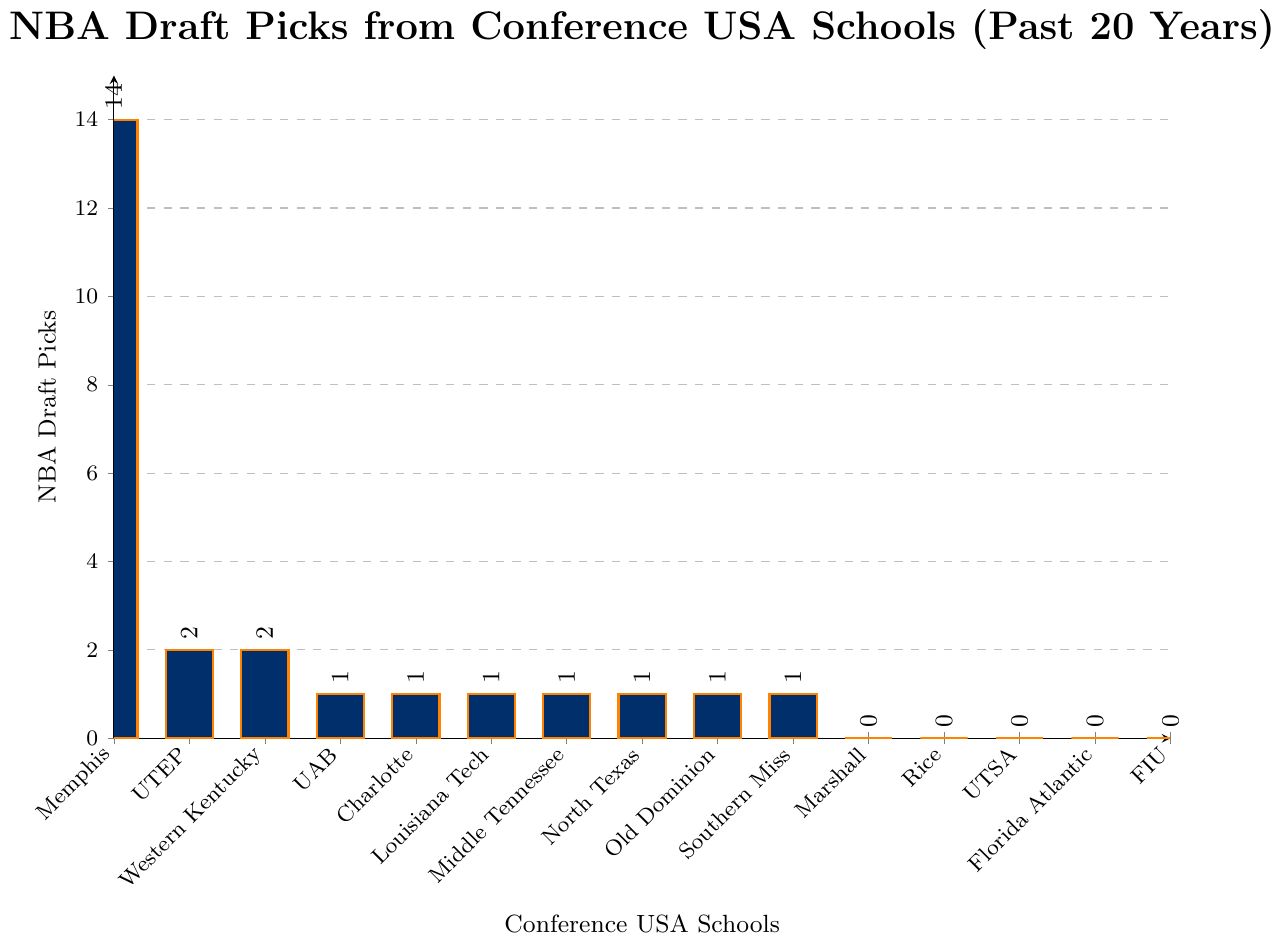Which school has the highest number of NBA draft picks? The tallest bar in the chart corresponds to Memphis, indicating it has the highest number of NBA draft picks.
Answer: Memphis How many schools have had exactly 1 NBA draft pick? Count the number of bars representing 1 draft pick. The schools are UAB, Charlotte, Louisiana Tech, Middle Tennessee, North Texas, Old Dominion, and Southern Miss.
Answer: 7 What is the total number of NBA draft picks from Conference USA schools represented in the chart? Add the NBA draft picks of all the schools: 14 (Memphis) + 2 (UTEP) + 2 (Western Kentucky) + 1 (UAB) + 1 (Charlotte) + 1 (Louisiana Tech) + 1 (Middle Tennessee) + 1 (North Texas) + 1 (Old Dominion) + 1 (Southern Miss) + 0 (all others) = 25
Answer: 25 Which schools have had zero NBA draft picks in the past 20 years? Identify the bars with a height of zero. The schools are Marshall, Rice, UTSA, Florida Atlantic, and FIU.
Answer: Marshall, Rice, UTSA, Florida Atlantic, FIU How many more NBA draft picks does Memphis have compared to UTEP? Subtract the number of UTEP's picks from Memphis's picks: 14 (Memphis) - 2 (UTEP) = 12
Answer: 12 What's the average number of NBA draft picks per school? Divide the total number of draft picks by the number of schools: Total number (25) / 15 schools = 1.67
Answer: 1.67 Which schools have an equal number of NBA draft picks? Check for bars of the same height: UTEP and Western Kentucky each have 2 draft picks, UAB, Charlotte, Louisiana Tech, Middle Tennessee, North Texas, Old Dominion, and Southern Miss each have 1 draft pick.
Answer: UTEP and Western Kentucky; UAB, Charlotte, Louisiana Tech, Middle Tennessee, North Texas, Old Dominion, and Southern Miss What's the difference in NBA draft picks between the school with the most picks and the school with the second most picks? Identify the top two schools: Memphis (14) and UTEP or Western Kentucky (2). Calculate the difference: 14 (Memphis) - 2 (UTEP or Western Kentucky) = 12
Answer: 12 